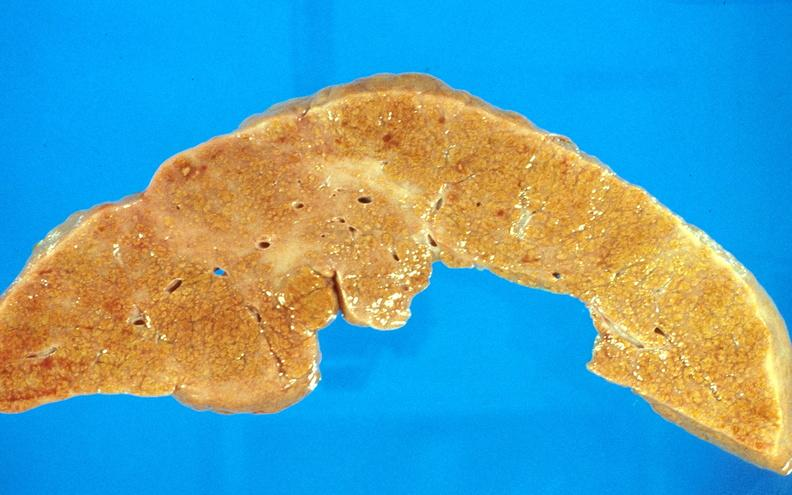s odontoid process subluxation with narrowing of foramen magnum present?
Answer the question using a single word or phrase. No 